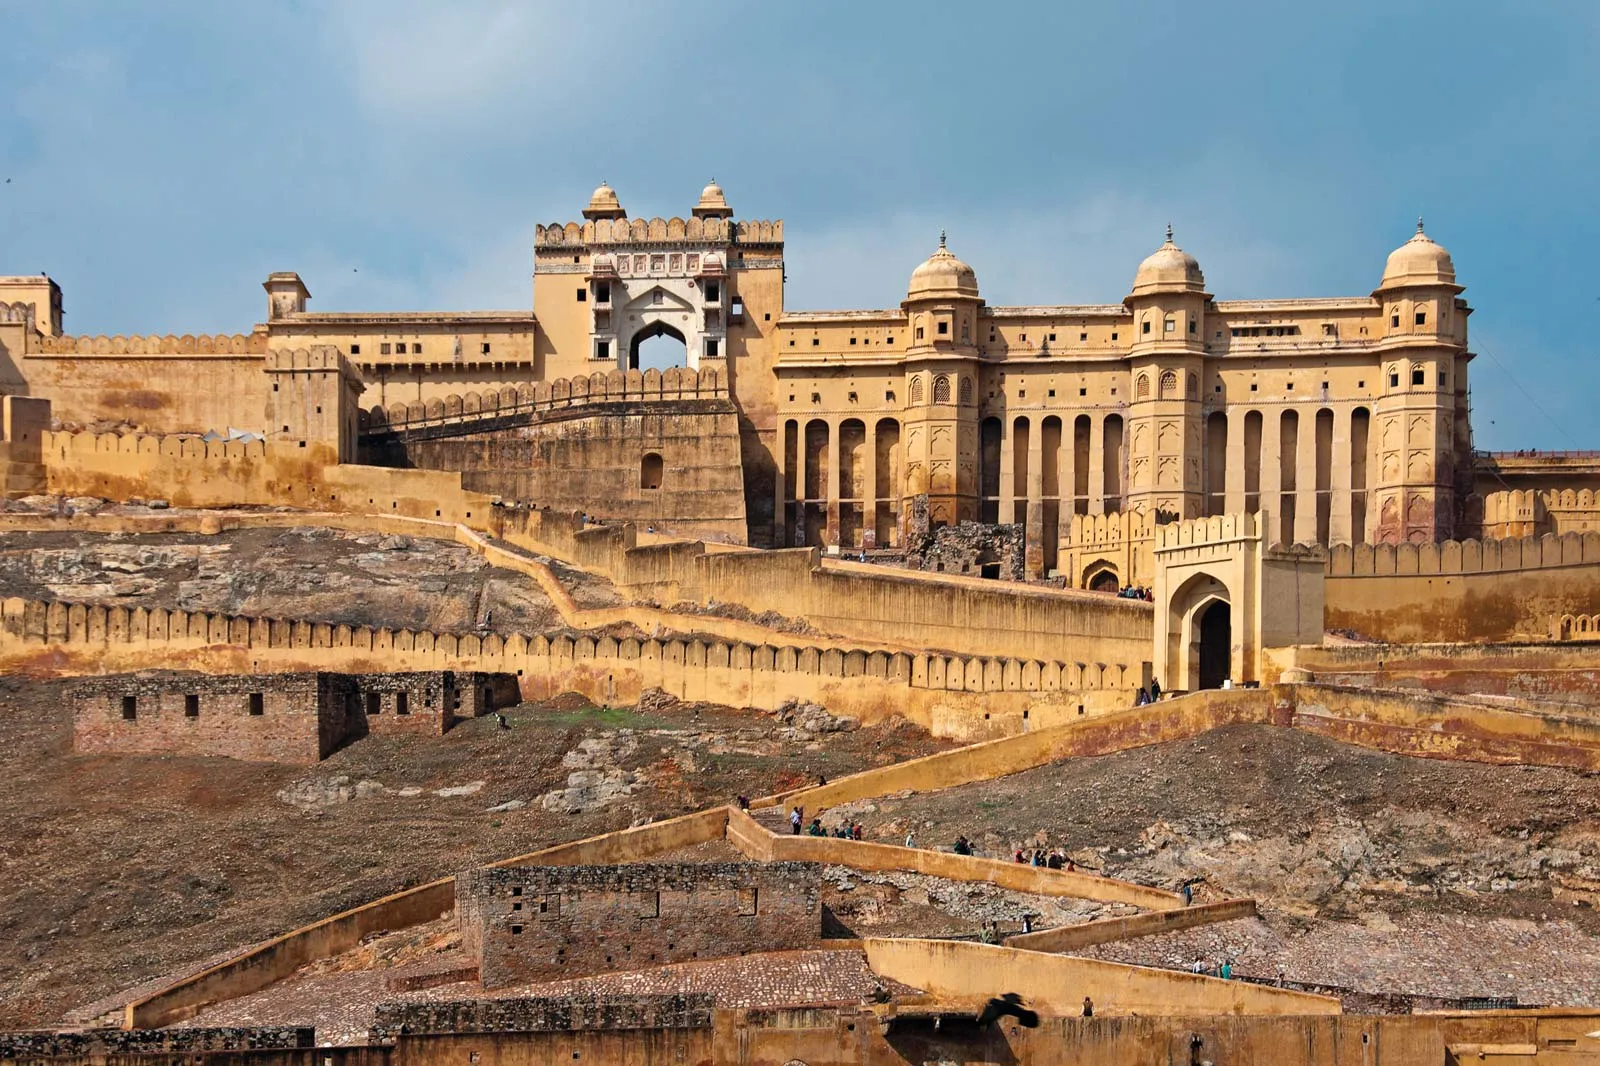Imagine a futuristic scene where this fort has been adapted with modern technology. Describe what you see. In a futuristic setting, Amber Fort would be an intriguing blend of historical charm and cutting-edge technology. The ancient sandstone walls and intricate carvings remain preserved, but are now augmented with holographic displays that provide interactive historical information to visitors. Drones buzz gently overhead, capturing and streaming live panoramic views of the fort and its surroundings. Virtual reality pods are scattered throughout the fort, allowing visitors to step into lifelike reenactments of historical events. Subtle solar panels, ingeniously integrated into the structure, provide sustainable energy, and glowing pathways guide tourists with augmented reality navigational aids. Robotic guides, dressed in traditional attire, move gracefully through the corridors, narrating stories of the past with precise, human-like articulation. A fusion of tranquility and innovation, this fort now serves as a high-tech museum, educating and mesmerizing tourists with both its rich history and its advanced adaptations. Can you describe a quick snapshot of a daily scene at this futuristic fort? A quick snapshot of a daily scene at the futuristic Amber Fort would show tourists donning smart glasses, receiving real-time information superimposed on their view of the ancient architecture. Interactive displays assist in translating local dialects and offering historical narratives. Children giggle as they interact with augmented reality displays, creating their digital graffiti on the fort's walls which vanish after a few seconds. Guided robots, mimicking the attire of erstwhile Rajput warriors, move swiftly among visitors, providing snippets of history. An ambient flow of holographic projections and futuristic light shows brings the rich past of the fort to life, while solar-powered autonomous cleaning bots ensure the fort remains pristine. 